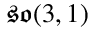Convert formula to latex. <formula><loc_0><loc_0><loc_500><loc_500>{ \mathfrak { s o } } ( 3 , 1 )</formula> 